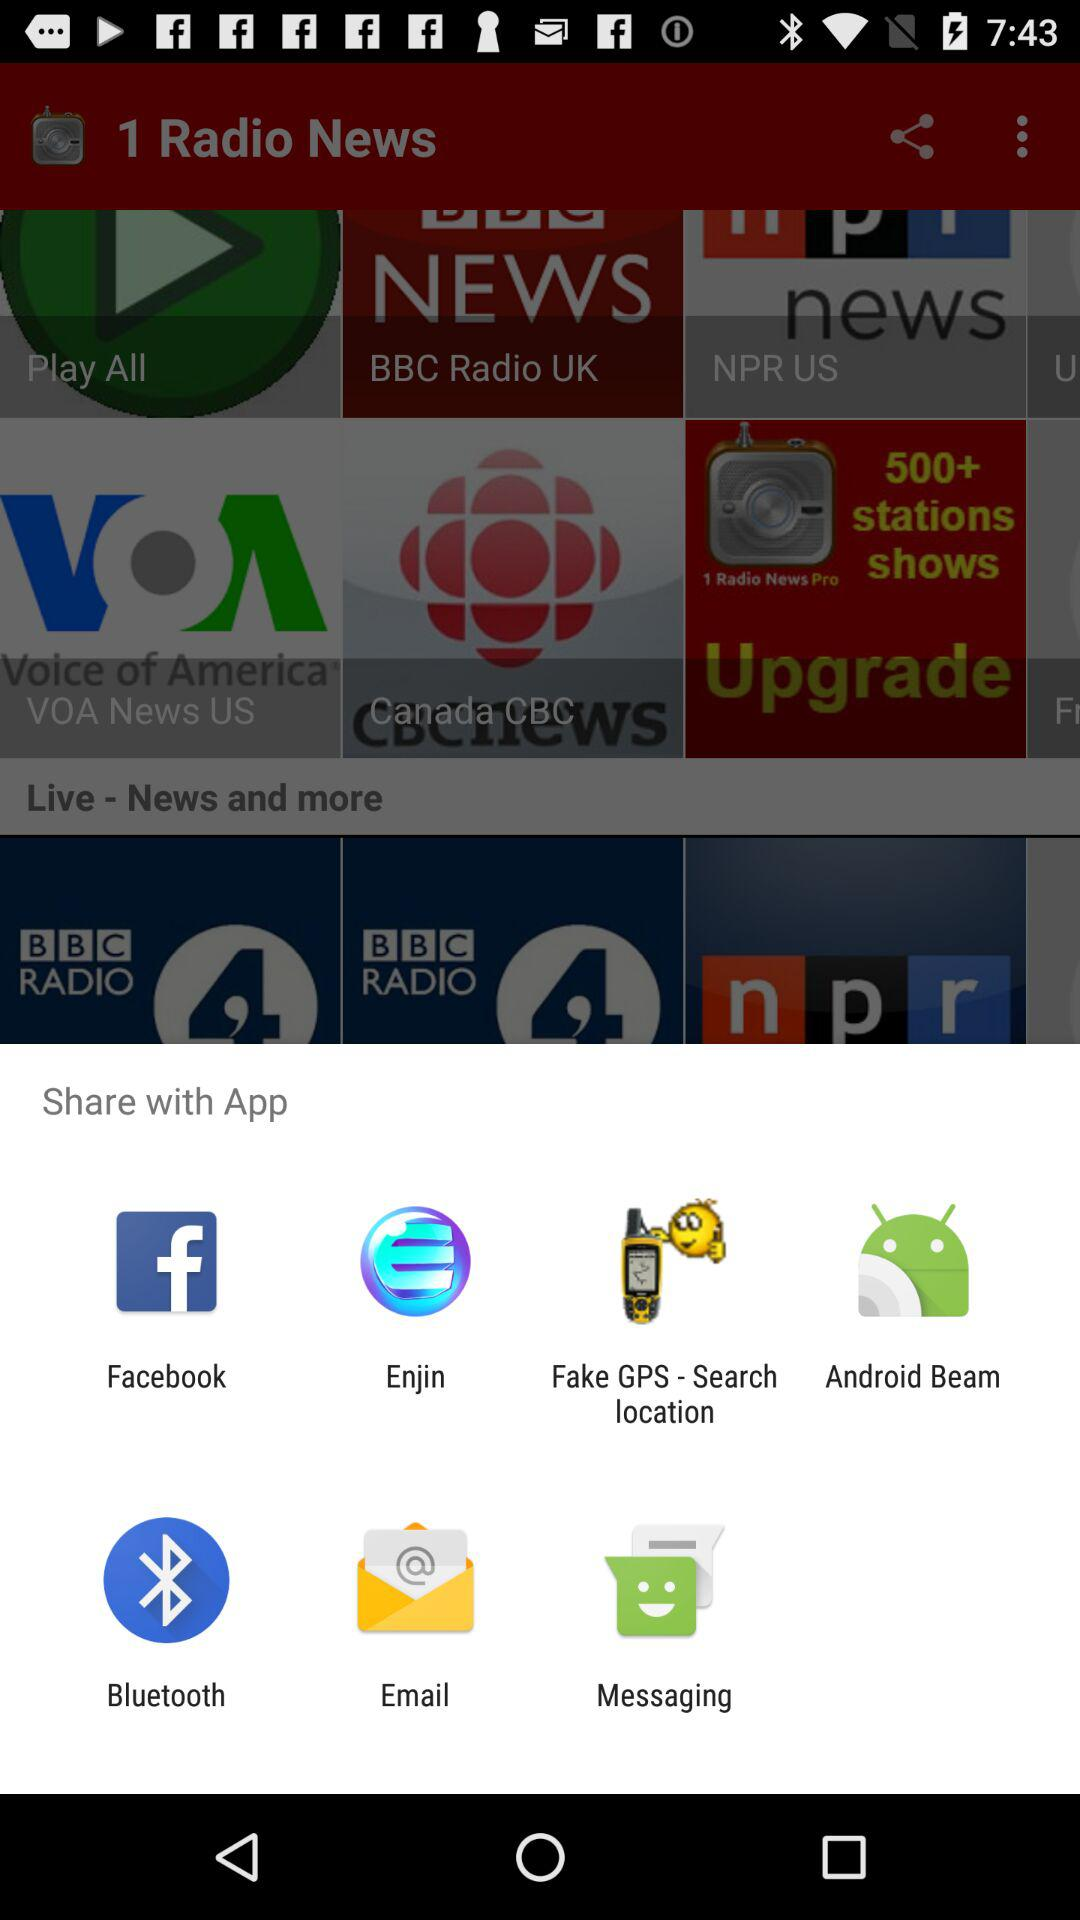Through which application can we share the news? You can share through "Facebook", "Enjin", "Fake GPS - Search location", "Android Beam", "Bluetooth", "Email" and "Messaging". 